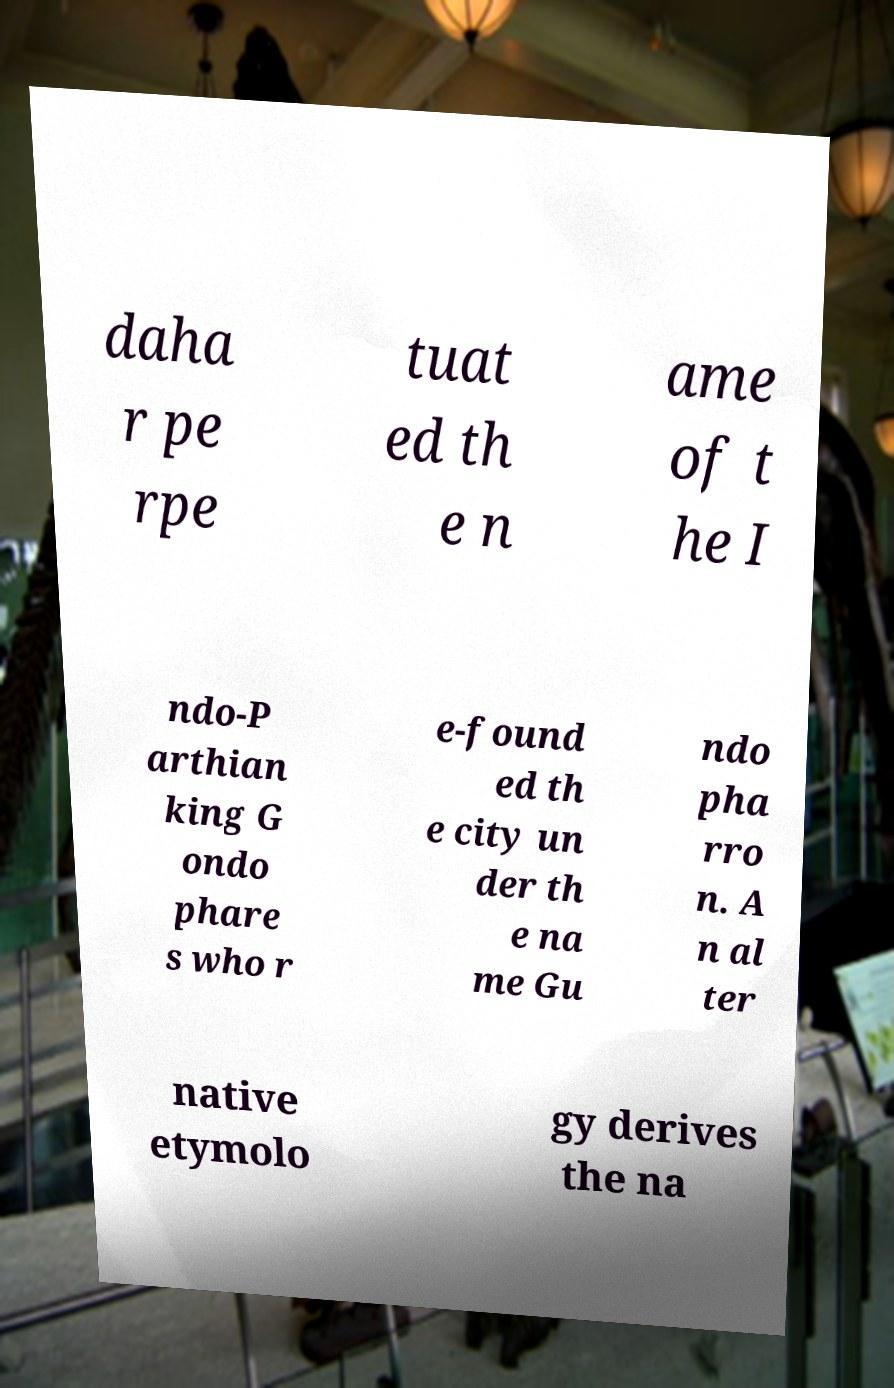Please read and relay the text visible in this image. What does it say? daha r pe rpe tuat ed th e n ame of t he I ndo-P arthian king G ondo phare s who r e-found ed th e city un der th e na me Gu ndo pha rro n. A n al ter native etymolo gy derives the na 